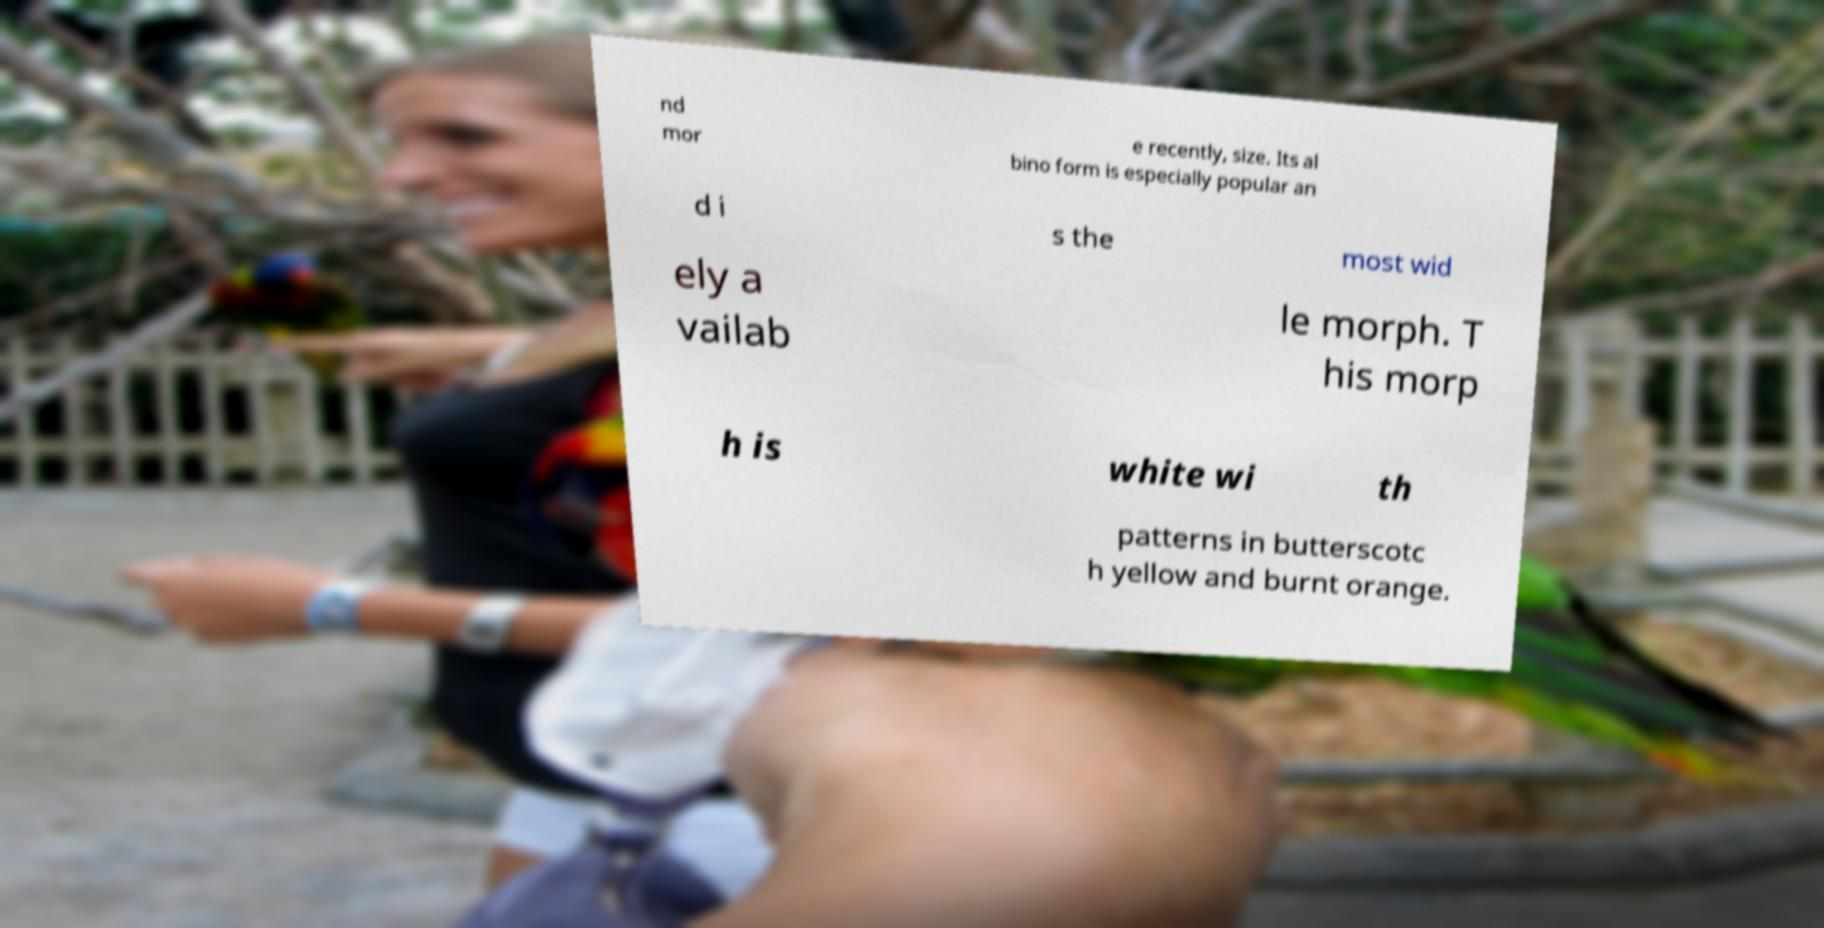Could you assist in decoding the text presented in this image and type it out clearly? nd mor e recently, size. Its al bino form is especially popular an d i s the most wid ely a vailab le morph. T his morp h is white wi th patterns in butterscotc h yellow and burnt orange. 